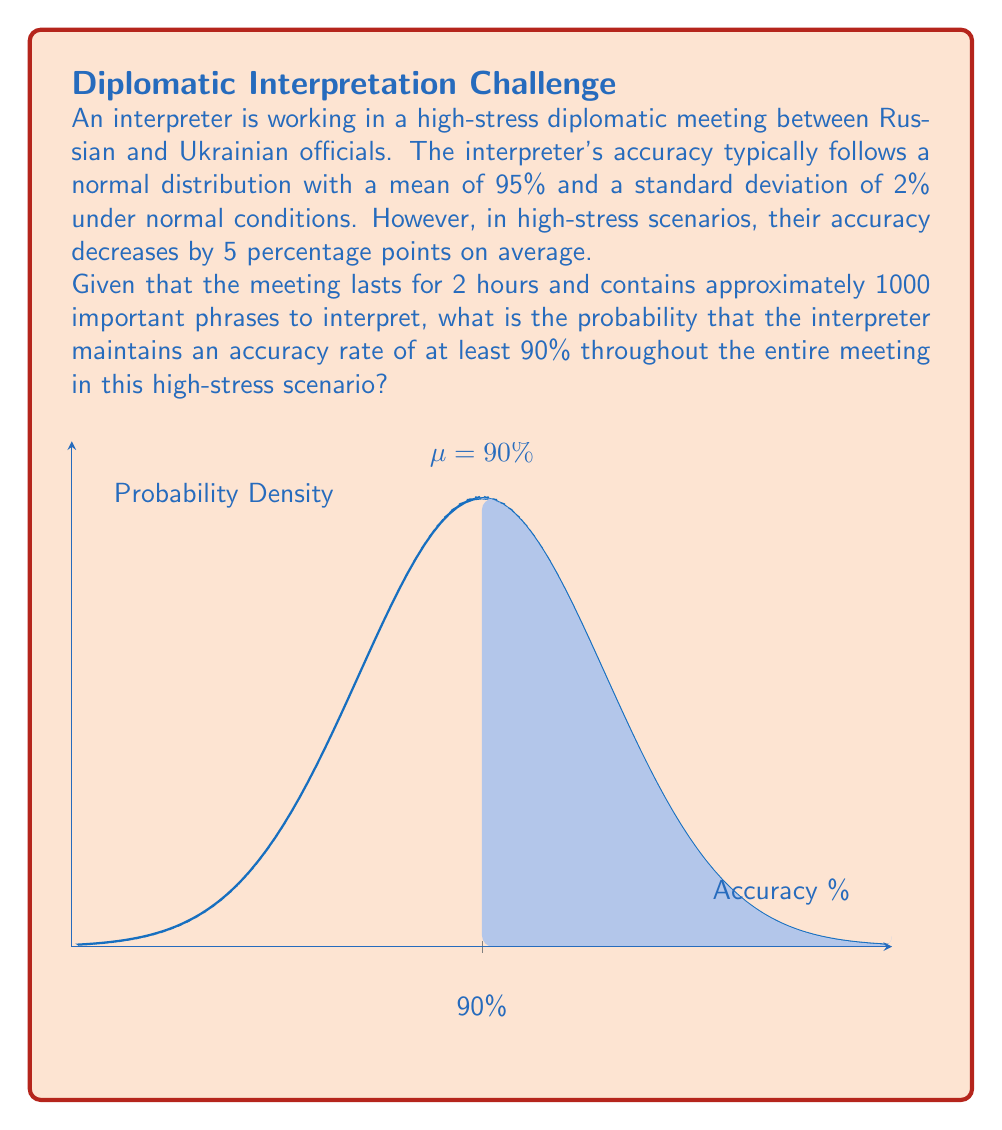Could you help me with this problem? Let's approach this step-by-step:

1) Under normal conditions, the accuracy follows $N(95, 2)$.

2) In high-stress scenarios, the mean decreases by 5 percentage points:
   New mean $\mu = 95\% - 5\% = 90\%$

3) We assume the standard deviation remains the same: $\sigma = 2\%$

4) We want to find $P(X \geq 90\%)$ where $X \sim N(90, 2)$

5) To standardize, we calculate the z-score:
   $z = \frac{x - \mu}{\sigma} = \frac{90 - 90}{2} = 0$

6) We need to find $P(Z \geq 0)$ where $Z$ is the standard normal distribution.

7) From the standard normal table or calculator:
   $P(Z \geq 0) = 0.5$

8) This is the probability for a single interpretation. However, we need the probability for maintaining this accuracy over 1000 phrases.

9) The probability of maintaining at least 90% accuracy for all 1000 phrases is:
   $P(\text{all} \geq 90\%) = (0.5)^{1000}$

10) Calculate:
    $(0.5)^{1000} \approx 9.33 \times 10^{-302}$

This extremely small probability indicates that it's virtually impossible to maintain at least 90% accuracy for all 1000 phrases under these high-stress conditions.
Answer: $9.33 \times 10^{-302}$ 